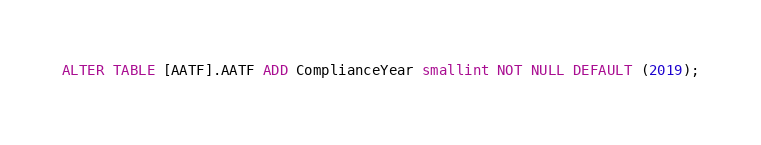<code> <loc_0><loc_0><loc_500><loc_500><_SQL_>ALTER TABLE [AATF].AATF ADD ComplianceYear smallint NOT NULL DEFAULT (2019);</code> 